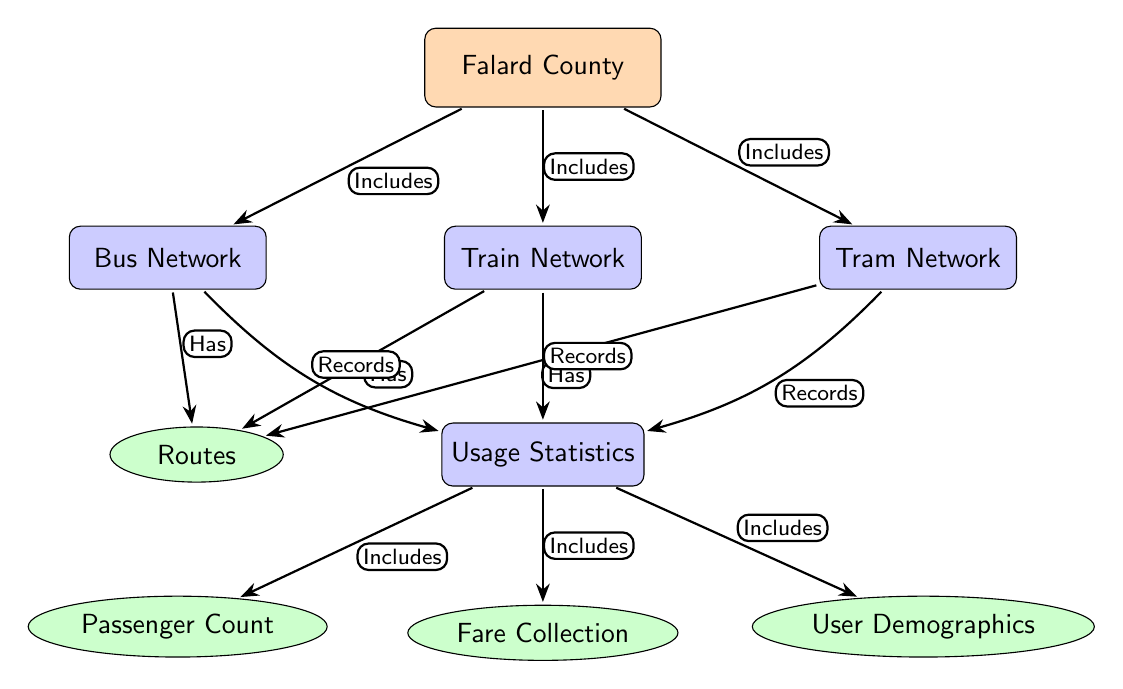What are the three transportation networks included in Falard County? The diagram lists three transportation networks: Bus Network, Train Network, and Tram Network. These are directly connected to the main node, Falard County.
Answer: Bus Network, Train Network, Tram Network How many leaf nodes are there in the Usage Statistics section? In the Usage Statistics section, there are four leaf nodes: Passenger Count, Fare Collection, Routes, and User Demographics. This can be counted directly from the diagram.
Answer: 4 What does the Bus Network do in relation to Usage Statistics? The Bus Network is connected to Usage Statistics with the label "Records," indicating that it records usage data related to its operations.
Answer: Records Which network includes routes? Each of the networks (Bus, Train, and Tram) has a connection labeled "Has" that points to Routes, meaning all networks include routes.
Answer: All networks What is the relationship between the Train Network and Usage Statistics? The Train Network connects to Usage Statistics with the edge labeled "Records," indicating that it also records its usage statistics.
Answer: Records List the component of Usage Statistics that provides information about users. The component that provides information about users is labeled "User Demographics" in the Usage Statistics section.
Answer: User Demographics What is the primary node in the diagram? The primary node at the top of the diagram is "Falard County." This is the main focus of the diagram, connecting to various transportation networks and usage statistics.
Answer: Falard County Identify the color representing the Bus Network in the diagram. The Bus Network node is filled with orange, while its edges are thick and directed, indicating its importance compared to other nodes.
Answer: Orange How are the Transportation Networks related to the usage statistics? Each Transportation Network (Bus, Train, Tram) connects to the Usage Statistics node with an edge labeled "Records," indicating a data collection relationship.
Answer: Records 